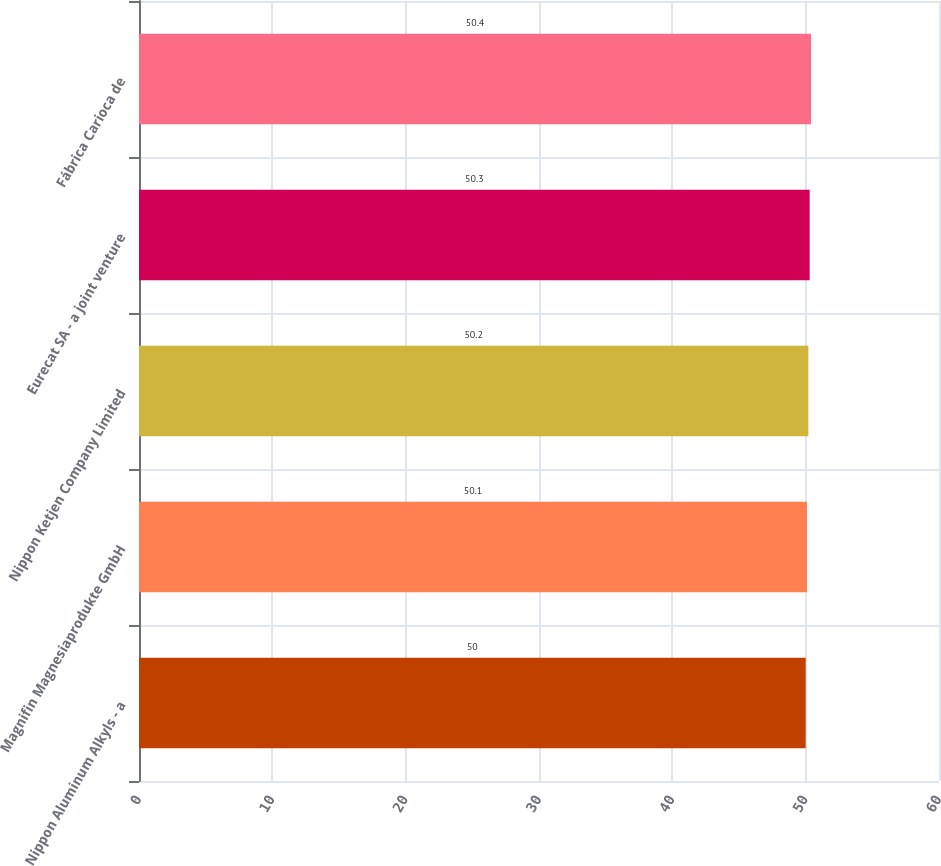Convert chart. <chart><loc_0><loc_0><loc_500><loc_500><bar_chart><fcel>Nippon Aluminum Alkyls - a<fcel>Magnifin Magnesiaprodukte GmbH<fcel>Nippon Ketjen Company Limited<fcel>Eurecat SA - a joint venture<fcel>Fábrica Carioca de<nl><fcel>50<fcel>50.1<fcel>50.2<fcel>50.3<fcel>50.4<nl></chart> 